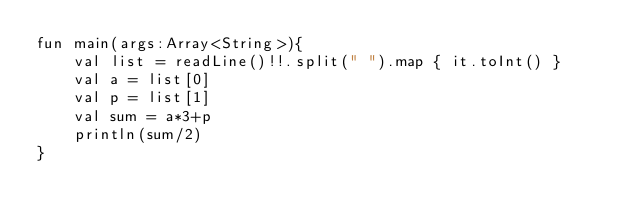Convert code to text. <code><loc_0><loc_0><loc_500><loc_500><_Kotlin_>fun main(args:Array<String>){
    val list = readLine()!!.split(" ").map { it.toInt() }
    val a = list[0]
    val p = list[1]
    val sum = a*3+p
    println(sum/2)
}</code> 